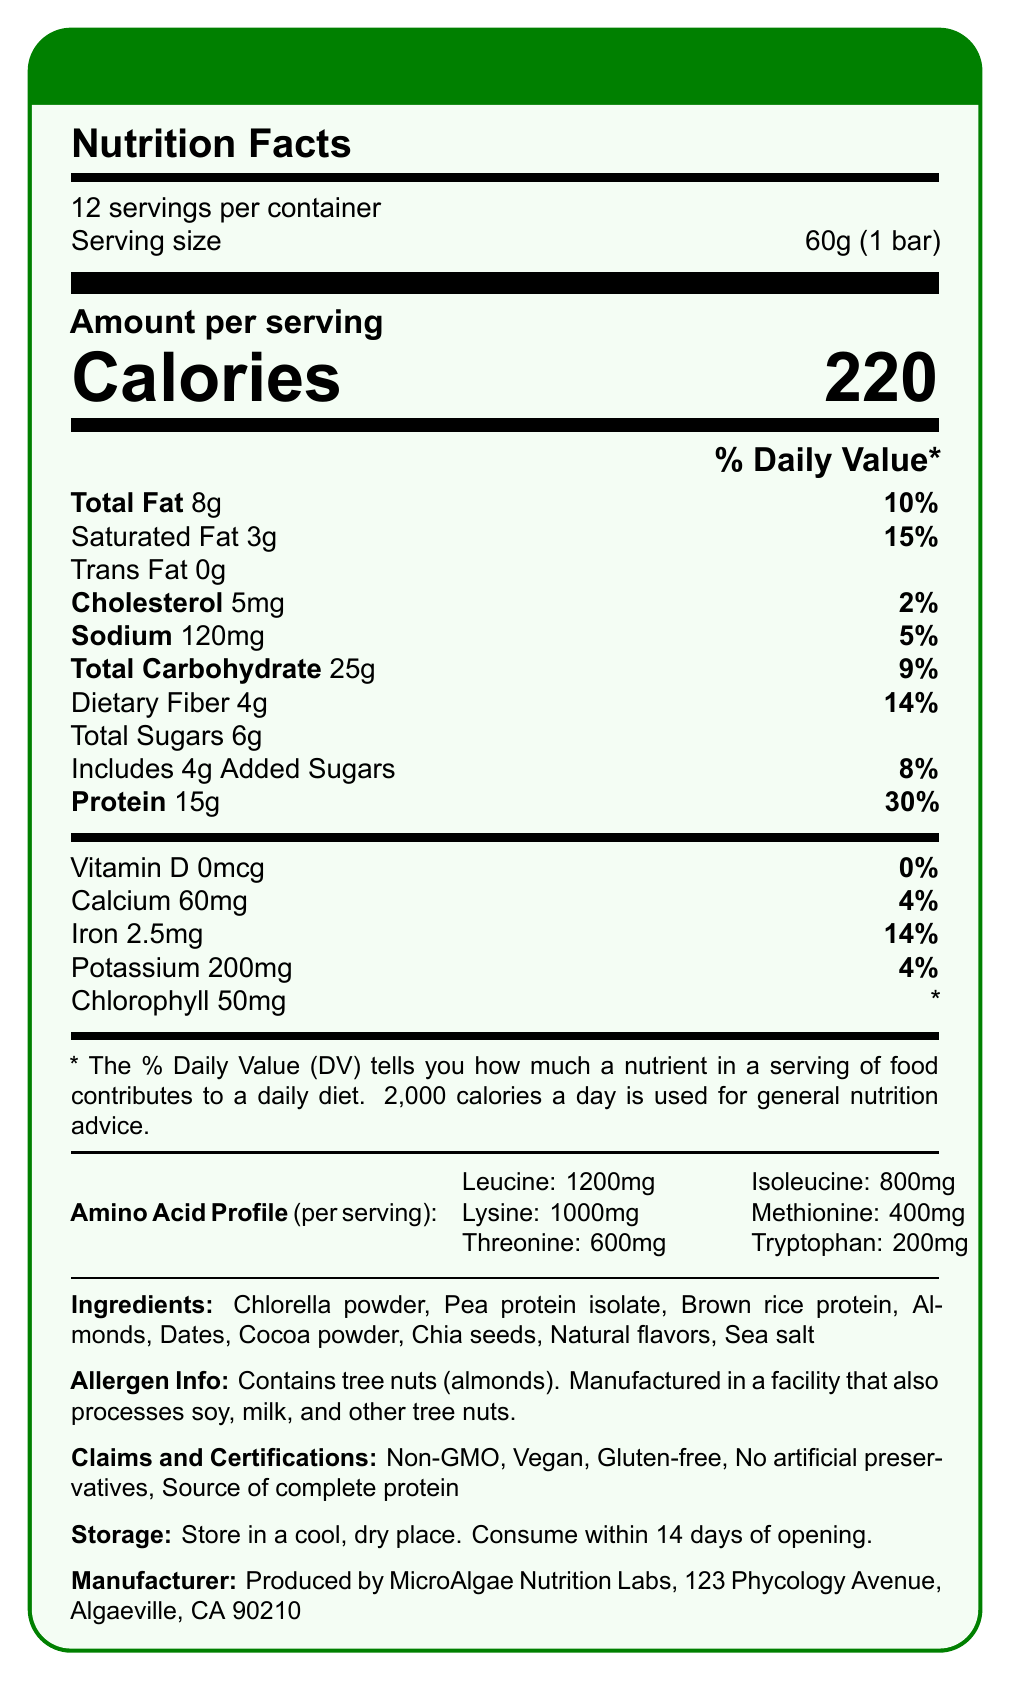what is the serving size of the AlgaeBoost Protein Bar? The serving size is stated directly in the document as "60g (1 bar)" under the serving size section.
Answer: 60g (1 bar) how many calories are in one AlgaeBoost Protein Bar? The document lists "Calories 220" under the Amount per serving section.
Answer: 220 calories how much protein is in one serving of the AlgaeBoost Protein Bar? The document indicates that each serving contains "Protein 15g" under the Amount per serving section.
Answer: 15g what is the amount of saturated fat in one serving of the AlgaeBoost Protein Bar? The document shows "Saturated Fat 3g" in the Total Fat section.
Answer: 3g how much chlorophyll is in one serving of the AlgaeBoost Protein Bar? The document lists "Chlorophyll 50mg" under the Vitamin and Minerals section.
Answer: 50mg which amino acid is present in the highest amount per serving? A. Lysine B. Leucine C. Valine D. Threonine The amino acid profile shows that Leucine has 1200mg, which is the highest among all listed amino acids.
Answer: B how many servings are in the entire package of AlgaeBoost Protein Bars? A. 10 B. 12 C. 14 D. 16 The document states "12 servings per container" which indicates option B is correct.
Answer: B does the AlgaeBoost Protein Bar contain any vitamin D? The document specifies "Vitamin D 0mcg" which means there is no Vitamin D in the bar.
Answer: No is the AlgaeBoost Protein Bar vegan? The Claims and Certifications section lists "Vegan" as one of the claims.
Answer: Yes summarize the main idea of the AlgaeBoost Protein Bar’s nutrition facts label. The document provides a detailed breakdown of nutrients, highlighting the protein and amino acid profile, chlorophyll content, ingredients, allergen information, and storage instructions.
Answer: The AlgaeBoost Protein Bar is a vegan, gluten-free snack that contains 220 calories per serving. It features chlorella powder for chlorophyll content and provides 15g of protein with a complete amino acid profile. The bar has 8g of total fat, with 3g of saturated fat, and contains essential vitamins and minerals like iron and potassium. It also has 50mg of chlorophyll per serving. what are the main ingredients in the AlgaeBoost Protein Bar? The Ingredients section lists these components as the main ingredients of the product.
Answer: Chlorella powder, Pea protein isolate, Brown rice protein, Almonds, Dates, Cocoa powder, Chia seeds, Natural flavors, Sea salt what certifications does the AlgaeBoost Protein Bar have? A. Non-GMO, B. Vegan C. Gluten-free D. All of the above The Claims and Certifications section lists "Non-GMO, Vegan, Gluten-free," and other claims, indicating that all these certifications apply.
Answer: D is there any artificial preservative in the AlgaeBoost Protein Bar? The document states "No artificial preservatives" in the Claims and Certifications section.
Answer: No how much sodium is in one serving of the AlgaeBoost Protein Bar? The Amount per serving section lists "Sodium 120mg" under the sodium content.
Answer: 120mg can you determine the exact manufacturing date of the AlgaeBoost Protein Bar from this document? The document does not provide any information about the manufacturing date, making it impossible to determine from the given data.
Answer: Cannot be determined 